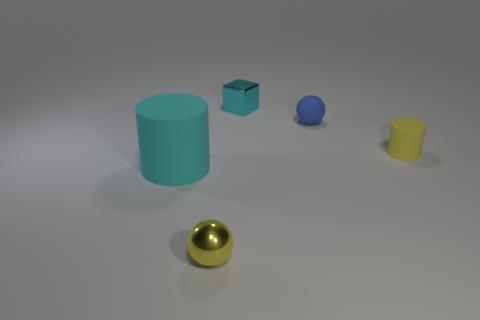Is there anything else that is the same shape as the small cyan object?
Offer a very short reply. No. There is a cylinder that is the same color as the small cube; what is its material?
Your response must be concise. Rubber. How big is the matte cylinder to the left of the sphere that is on the left side of the small ball to the right of the cyan block?
Your answer should be very brief. Large. Do the small yellow rubber object and the cyan object that is to the left of the cube have the same shape?
Your answer should be compact. Yes. Are there any rubber things of the same color as the shiny ball?
Keep it short and to the point. Yes. What number of cylinders are either matte objects or blue things?
Your answer should be very brief. 2. Is there a yellow metallic object of the same shape as the small blue matte object?
Your answer should be compact. Yes. What number of other things are the same color as the small cylinder?
Provide a short and direct response. 1. Is the number of rubber things that are right of the small yellow cylinder less than the number of tiny cyan things?
Keep it short and to the point. Yes. What number of matte cylinders are there?
Make the answer very short. 2. 